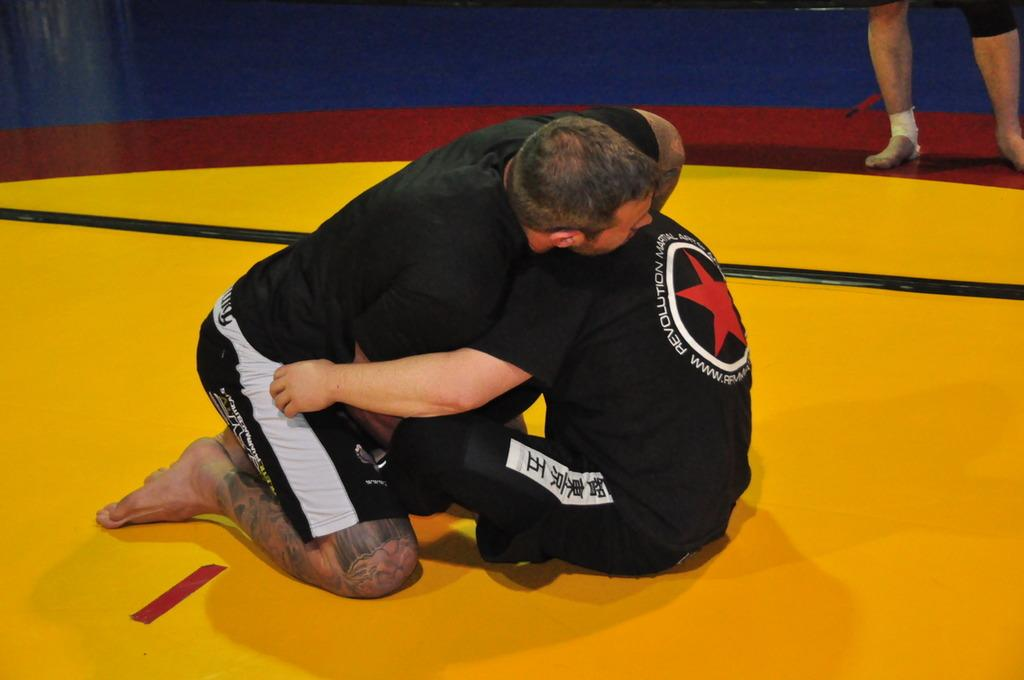Provide a one-sentence caption for the provided image. the word revolution that is on a shirt. 